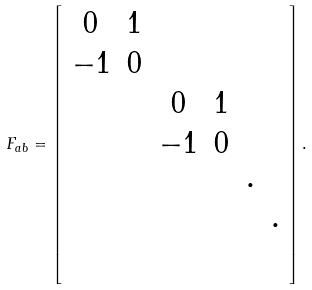<formula> <loc_0><loc_0><loc_500><loc_500>F _ { a b } = \left [ \begin{array} { c c c c c c } 0 & 1 & & & & \\ - 1 & 0 & & & & \\ & & 0 & 1 & & \\ & & - 1 & 0 & & \\ & & & & \cdot & \\ & & & & & \cdot \\ & & & & & \end{array} \right ] .</formula> 